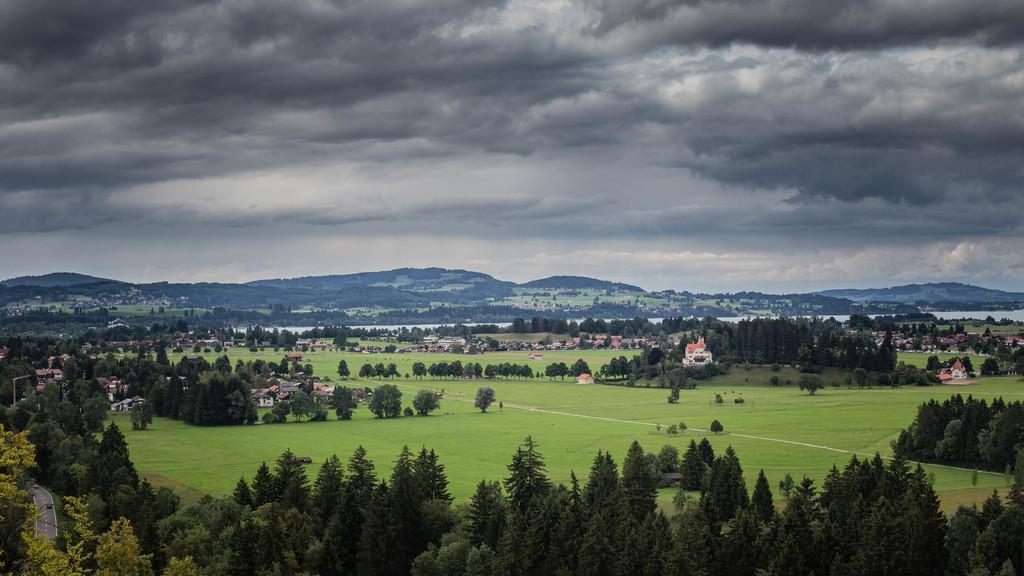What type of vegetation is present in the image? There are trees in the image. What type of structures can be seen in the image? There are houses in the image. What is the ground covered with in the image? There is grass in the image. What natural feature is present in the image? There is water in the image. What type of landscape can be seen in the image? There are mountains in the image. What is visible in the background of the image? The sky is visible in the background of the image. What can be seen in the sky? There are clouds in the sky. How many cats are playing on the roof of the houses in the image? There are no cats present in the image; it features trees, houses, grass, water, mountains, and the sky. What type of cemetery can be seen in the image? There is no cemetery present in the image. 